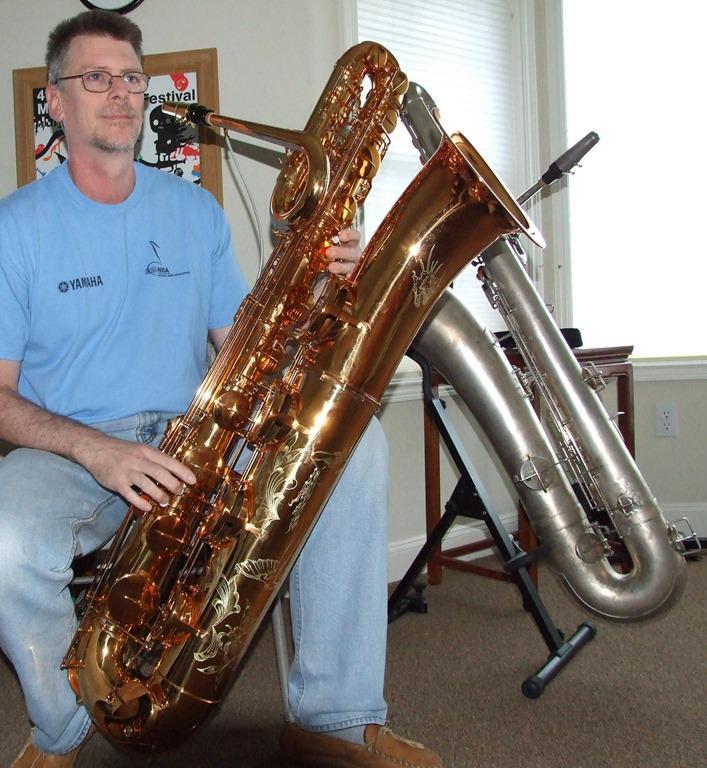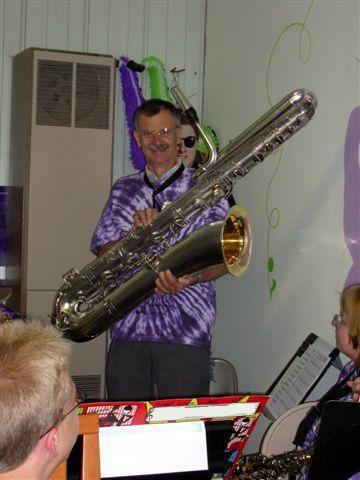The first image is the image on the left, the second image is the image on the right. Examine the images to the left and right. Is the description "Two people are playing instruments." accurate? Answer yes or no. No. 